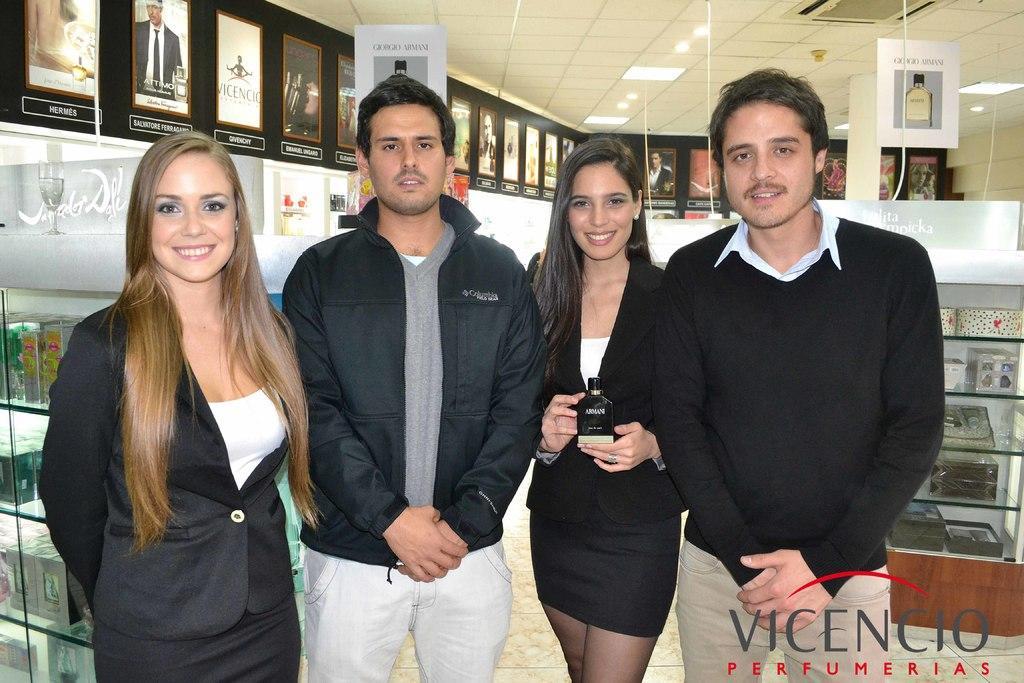Can you describe this image briefly? In the center of the image we can see four people are standing and a lady is holding an object. In the background of the image we can see the boards on the wall, racks. In the racks we can see some objects. At the bottom of the image we can see the floor. In the bottom right corner we can see the text. At the top of the image we can see the roof and lights. 